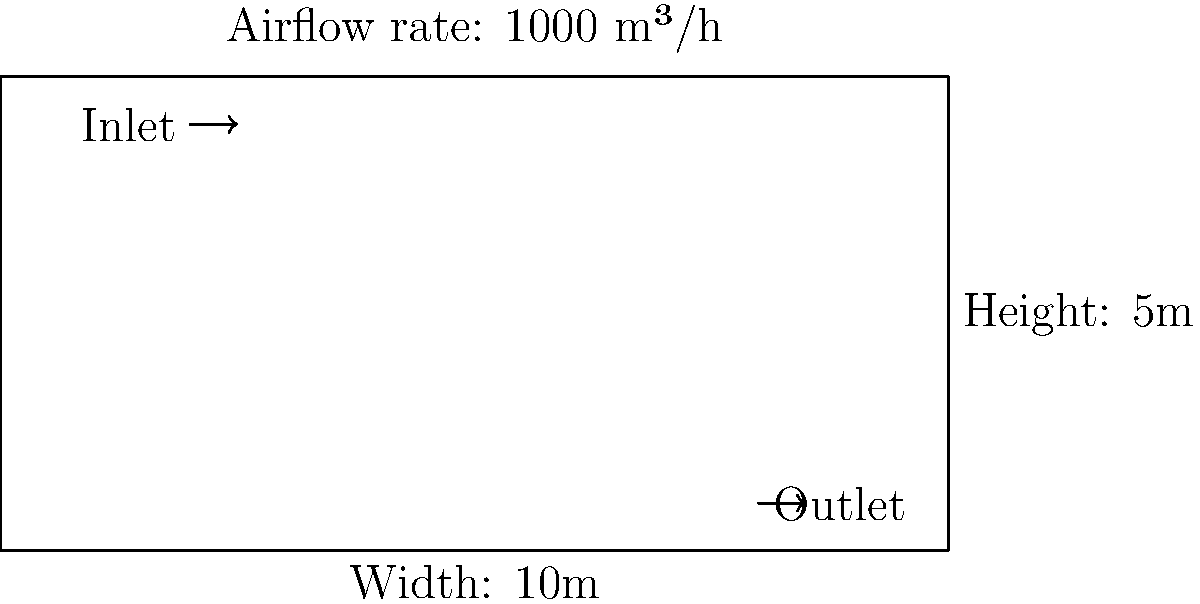As a bakery owner implementing safety measures, you need to calculate the air exchange rate in your establishment. Given the ventilation system diagram of your bakery shown above, with dimensions of 10m x 5m x 8m (width x height x depth) and an airflow rate of 1000 m³/h, what is the air exchange rate per hour? To calculate the air exchange rate per hour, we need to follow these steps:

1. Calculate the volume of the bakery:
   $$V = \text{width} \times \text{height} \times \text{depth}$$
   $$V = 10 \text{ m} \times 5 \text{ m} \times 8 \text{ m} = 400 \text{ m}^3$$

2. Identify the airflow rate:
   Airflow rate = 1000 m³/h

3. Calculate the air exchange rate per hour:
   $$\text{Air Exchange Rate} = \frac{\text{Airflow Rate}}{\text{Room Volume}}$$
   $$\text{Air Exchange Rate} = \frac{1000 \text{ m}^3/\text{h}}{400 \text{ m}^3}$$
   $$\text{Air Exchange Rate} = 2.5 \text{ h}^{-1}$$

This means that the entire volume of air in the bakery is replaced 2.5 times every hour.
Answer: 2.5 h⁻¹ 